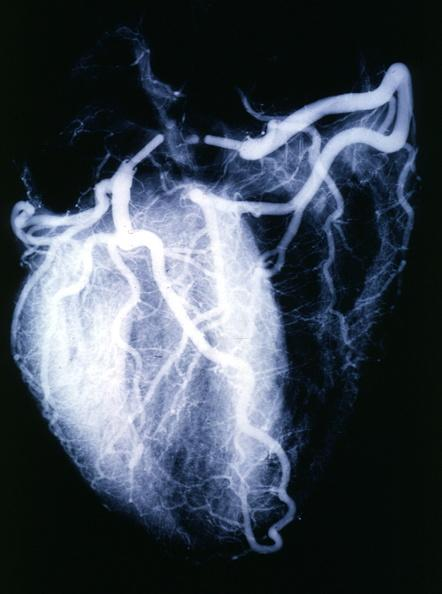s rocky mountain present?
Answer the question using a single word or phrase. No 